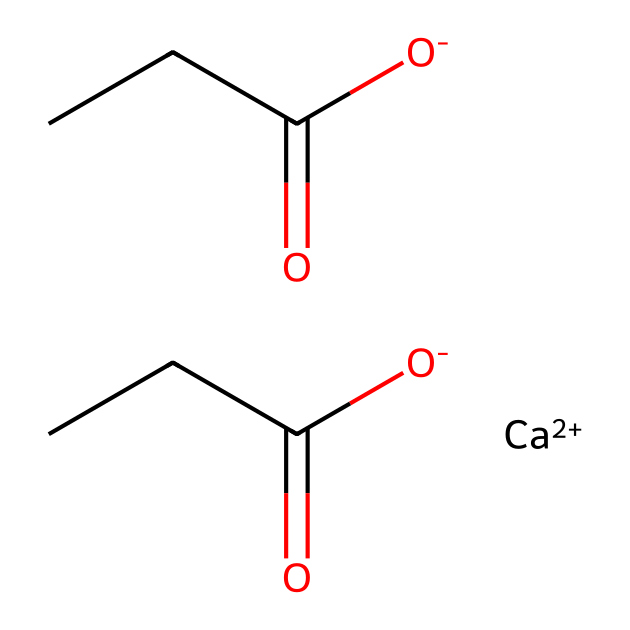What is the chemical name of this compound? The chemical name derived from its structure, which consists of calcium and propionic acid, is calcium propionate.
Answer: calcium propionate How many carbon atoms are present in the structure? Analyzing the SMILES representation, we count 4 carbon atoms from the two propionate groups (C(=O)CC) plus one from the calcium coordination, totaling 4.
Answer: four What type of chemical is calcium propionate? Calcium propionate is categorized as a food preservative, specifically a salt of propionic acid, which helps to inhibit mold and bacteria growth.
Answer: preservative How many oxygen atoms are in the molecule? By examining the structure, calcium propionate contains four oxygen atoms from the two carboxylic acid groups (two C(=O) and two O-).
Answer: four Which part of the molecule acts as the preservative? The propionic acid moiety (C(=O)CC) serves as the active part that inhibits microbial growth, making the compound effective as a preservative.
Answer: propionic acid What type of bond exists between the calcium and the propionate? The bond between calcium and the propionate part of the molecule is an ionic bond, as calcium typically forms ionic compounds with anions like propionate.
Answer: ionic bond 